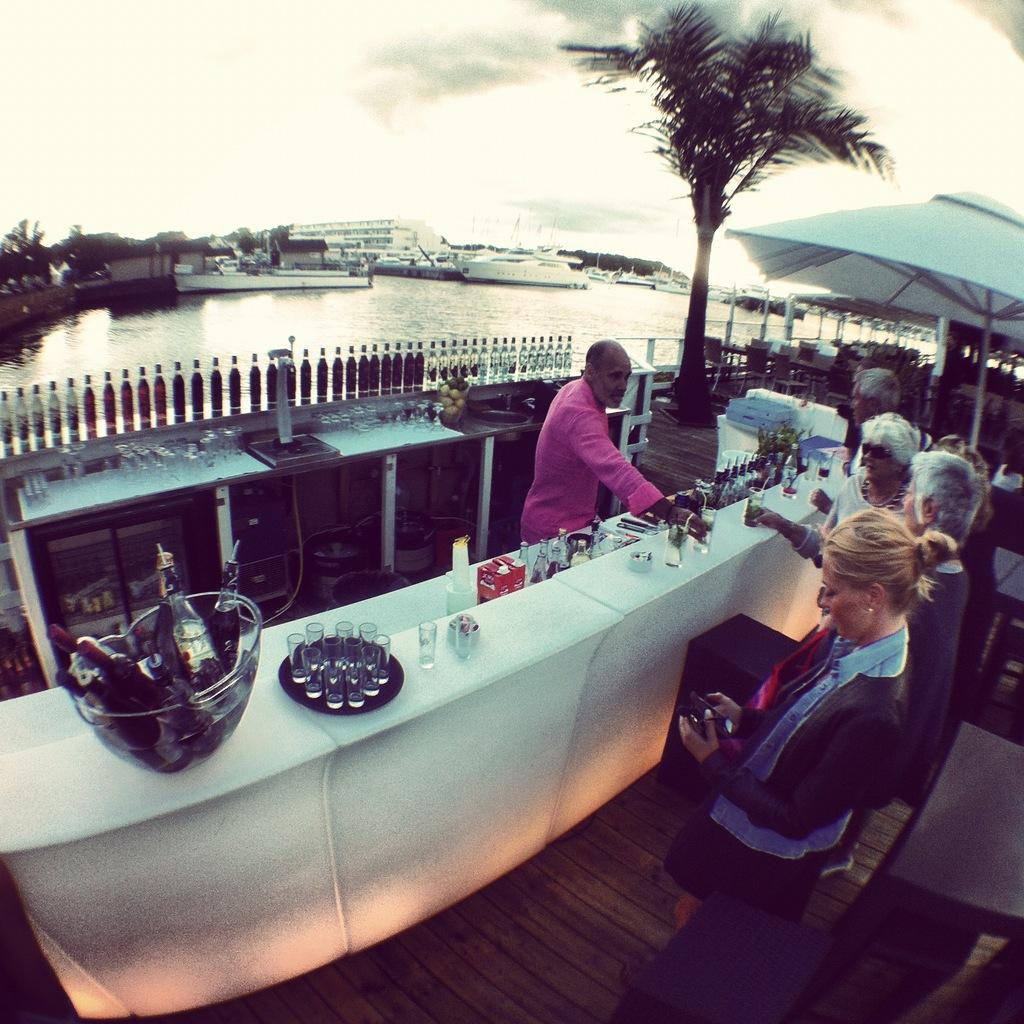What type of establishment is shown in the image? There is a cafeteria in the image. What is the man in the image doing? A man is serving drinks in the image. Can you describe the people in the image? There is a group of people in the image. What can be seen on the table or counter in the image? There are bottles visible in the image. What natural element is visible in the background of the image? There is a tree in the image. What can be seen in the distance behind the tree? There is a sea visible in the background of the image. What type of boot is being worn by the man serving drinks in the image? There is no mention of a boot or any footwear in the image, so it cannot be determined. What is the man's stomach doing while serving drinks in the image? There is no information about the man's stomach in the image, so it cannot be determined. 